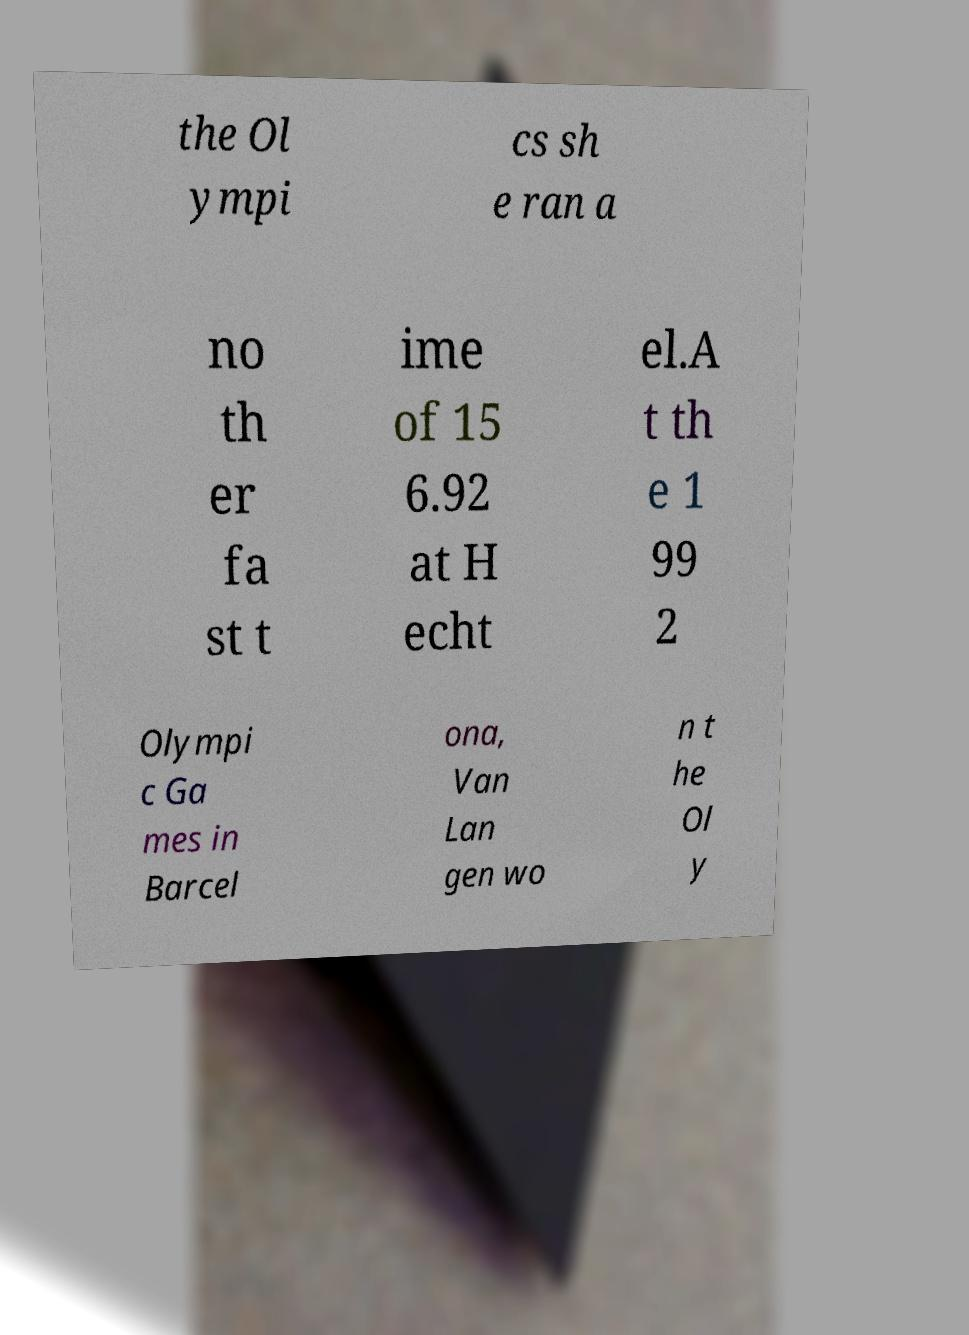For documentation purposes, I need the text within this image transcribed. Could you provide that? the Ol ympi cs sh e ran a no th er fa st t ime of 15 6.92 at H echt el.A t th e 1 99 2 Olympi c Ga mes in Barcel ona, Van Lan gen wo n t he Ol y 